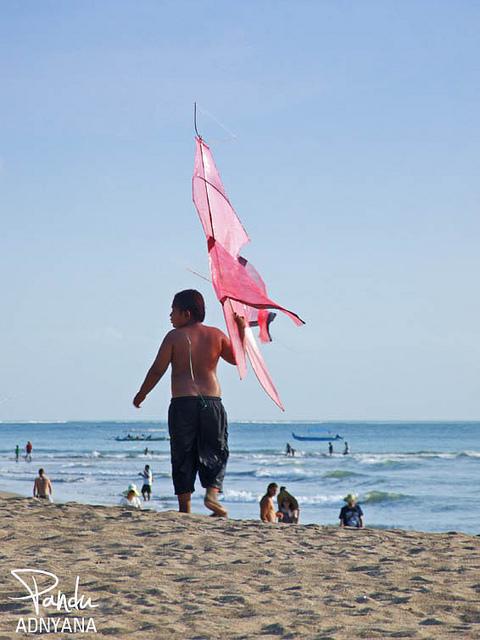Was this picture taken on land?
Be succinct. Yes. Are there clouds in the sky?
Be succinct. No. Overcast or sunny?
Write a very short answer. Sunny. Are there boats in the background?
Answer briefly. Yes. 